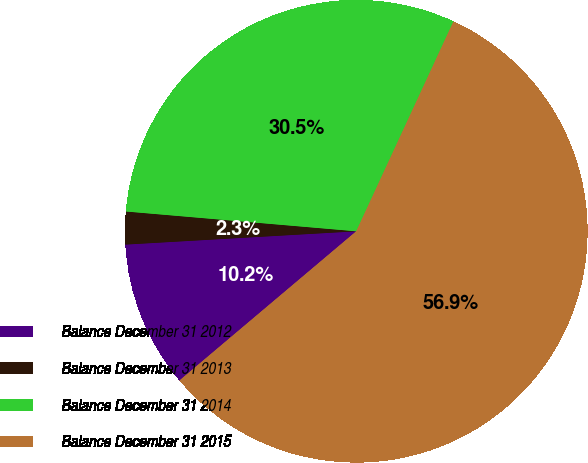Convert chart. <chart><loc_0><loc_0><loc_500><loc_500><pie_chart><fcel>Balance December 31 2012<fcel>Balance December 31 2013<fcel>Balance December 31 2014<fcel>Balance December 31 2015<nl><fcel>10.24%<fcel>2.28%<fcel>30.54%<fcel>56.94%<nl></chart> 